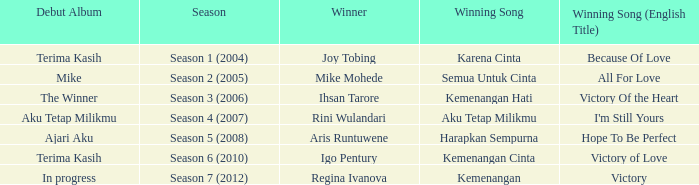Which winning song was sung by aku tetap milikmu? I'm Still Yours. 